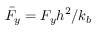<formula> <loc_0><loc_0><loc_500><loc_500>\bar { F } _ { y } = F _ { y } h ^ { 2 } / k _ { b }</formula> 